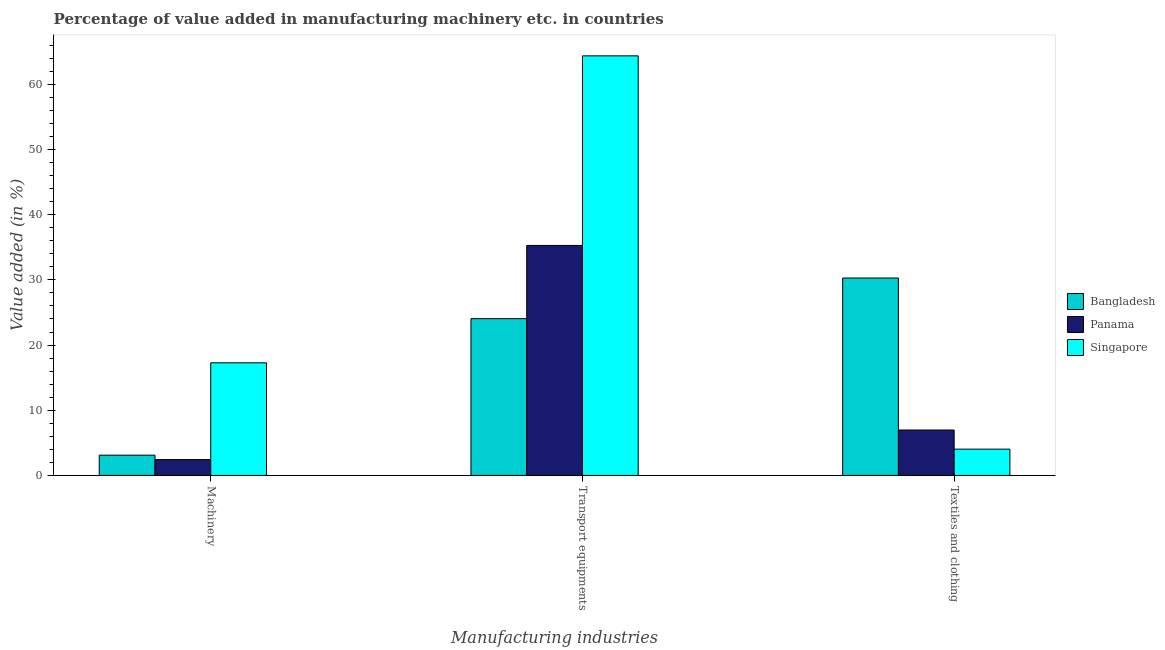How many different coloured bars are there?
Keep it short and to the point. 3. How many groups of bars are there?
Your response must be concise. 3. Are the number of bars per tick equal to the number of legend labels?
Your answer should be compact. Yes. Are the number of bars on each tick of the X-axis equal?
Offer a terse response. Yes. What is the label of the 1st group of bars from the left?
Keep it short and to the point. Machinery. What is the value added in manufacturing machinery in Bangladesh?
Give a very brief answer. 3.11. Across all countries, what is the maximum value added in manufacturing transport equipments?
Offer a terse response. 64.36. Across all countries, what is the minimum value added in manufacturing textile and clothing?
Your answer should be very brief. 4.04. In which country was the value added in manufacturing machinery maximum?
Keep it short and to the point. Singapore. In which country was the value added in manufacturing machinery minimum?
Ensure brevity in your answer.  Panama. What is the total value added in manufacturing machinery in the graph?
Your answer should be very brief. 22.82. What is the difference between the value added in manufacturing machinery in Bangladesh and that in Panama?
Offer a terse response. 0.68. What is the difference between the value added in manufacturing textile and clothing in Bangladesh and the value added in manufacturing transport equipments in Singapore?
Ensure brevity in your answer.  -34.07. What is the average value added in manufacturing transport equipments per country?
Offer a terse response. 41.23. What is the difference between the value added in manufacturing machinery and value added in manufacturing transport equipments in Singapore?
Give a very brief answer. -47.08. What is the ratio of the value added in manufacturing textile and clothing in Panama to that in Bangladesh?
Keep it short and to the point. 0.23. What is the difference between the highest and the second highest value added in manufacturing machinery?
Make the answer very short. 14.16. What is the difference between the highest and the lowest value added in manufacturing machinery?
Your answer should be compact. 14.84. In how many countries, is the value added in manufacturing textile and clothing greater than the average value added in manufacturing textile and clothing taken over all countries?
Provide a short and direct response. 1. Is the sum of the value added in manufacturing machinery in Singapore and Bangladesh greater than the maximum value added in manufacturing transport equipments across all countries?
Ensure brevity in your answer.  No. What does the 2nd bar from the left in Textiles and clothing represents?
Ensure brevity in your answer.  Panama. What does the 2nd bar from the right in Transport equipments represents?
Ensure brevity in your answer.  Panama. Is it the case that in every country, the sum of the value added in manufacturing machinery and value added in manufacturing transport equipments is greater than the value added in manufacturing textile and clothing?
Your response must be concise. No. How many bars are there?
Give a very brief answer. 9. Does the graph contain grids?
Give a very brief answer. No. How many legend labels are there?
Offer a very short reply. 3. What is the title of the graph?
Ensure brevity in your answer.  Percentage of value added in manufacturing machinery etc. in countries. What is the label or title of the X-axis?
Your response must be concise. Manufacturing industries. What is the label or title of the Y-axis?
Your answer should be compact. Value added (in %). What is the Value added (in %) of Bangladesh in Machinery?
Ensure brevity in your answer.  3.11. What is the Value added (in %) of Panama in Machinery?
Keep it short and to the point. 2.43. What is the Value added (in %) of Singapore in Machinery?
Keep it short and to the point. 17.28. What is the Value added (in %) of Bangladesh in Transport equipments?
Ensure brevity in your answer.  24.05. What is the Value added (in %) in Panama in Transport equipments?
Your response must be concise. 35.28. What is the Value added (in %) of Singapore in Transport equipments?
Your answer should be compact. 64.36. What is the Value added (in %) of Bangladesh in Textiles and clothing?
Ensure brevity in your answer.  30.28. What is the Value added (in %) in Panama in Textiles and clothing?
Your answer should be compact. 6.97. What is the Value added (in %) in Singapore in Textiles and clothing?
Your answer should be very brief. 4.04. Across all Manufacturing industries, what is the maximum Value added (in %) of Bangladesh?
Your response must be concise. 30.28. Across all Manufacturing industries, what is the maximum Value added (in %) of Panama?
Offer a very short reply. 35.28. Across all Manufacturing industries, what is the maximum Value added (in %) in Singapore?
Provide a succinct answer. 64.36. Across all Manufacturing industries, what is the minimum Value added (in %) of Bangladesh?
Give a very brief answer. 3.11. Across all Manufacturing industries, what is the minimum Value added (in %) of Panama?
Ensure brevity in your answer.  2.43. Across all Manufacturing industries, what is the minimum Value added (in %) in Singapore?
Offer a terse response. 4.04. What is the total Value added (in %) of Bangladesh in the graph?
Offer a terse response. 57.45. What is the total Value added (in %) of Panama in the graph?
Offer a very short reply. 44.68. What is the total Value added (in %) in Singapore in the graph?
Your response must be concise. 85.67. What is the difference between the Value added (in %) of Bangladesh in Machinery and that in Transport equipments?
Offer a terse response. -20.94. What is the difference between the Value added (in %) in Panama in Machinery and that in Transport equipments?
Keep it short and to the point. -32.84. What is the difference between the Value added (in %) in Singapore in Machinery and that in Transport equipments?
Your answer should be very brief. -47.08. What is the difference between the Value added (in %) of Bangladesh in Machinery and that in Textiles and clothing?
Give a very brief answer. -27.17. What is the difference between the Value added (in %) of Panama in Machinery and that in Textiles and clothing?
Make the answer very short. -4.54. What is the difference between the Value added (in %) of Singapore in Machinery and that in Textiles and clothing?
Offer a terse response. 13.24. What is the difference between the Value added (in %) in Bangladesh in Transport equipments and that in Textiles and clothing?
Offer a terse response. -6.23. What is the difference between the Value added (in %) in Panama in Transport equipments and that in Textiles and clothing?
Your response must be concise. 28.31. What is the difference between the Value added (in %) of Singapore in Transport equipments and that in Textiles and clothing?
Offer a terse response. 60.32. What is the difference between the Value added (in %) in Bangladesh in Machinery and the Value added (in %) in Panama in Transport equipments?
Your answer should be very brief. -32.16. What is the difference between the Value added (in %) in Bangladesh in Machinery and the Value added (in %) in Singapore in Transport equipments?
Provide a short and direct response. -61.24. What is the difference between the Value added (in %) of Panama in Machinery and the Value added (in %) of Singapore in Transport equipments?
Your answer should be compact. -61.92. What is the difference between the Value added (in %) of Bangladesh in Machinery and the Value added (in %) of Panama in Textiles and clothing?
Give a very brief answer. -3.86. What is the difference between the Value added (in %) of Bangladesh in Machinery and the Value added (in %) of Singapore in Textiles and clothing?
Offer a terse response. -0.92. What is the difference between the Value added (in %) in Panama in Machinery and the Value added (in %) in Singapore in Textiles and clothing?
Provide a short and direct response. -1.6. What is the difference between the Value added (in %) in Bangladesh in Transport equipments and the Value added (in %) in Panama in Textiles and clothing?
Keep it short and to the point. 17.08. What is the difference between the Value added (in %) in Bangladesh in Transport equipments and the Value added (in %) in Singapore in Textiles and clothing?
Your answer should be very brief. 20.02. What is the difference between the Value added (in %) in Panama in Transport equipments and the Value added (in %) in Singapore in Textiles and clothing?
Ensure brevity in your answer.  31.24. What is the average Value added (in %) in Bangladesh per Manufacturing industries?
Your response must be concise. 19.15. What is the average Value added (in %) of Panama per Manufacturing industries?
Offer a very short reply. 14.89. What is the average Value added (in %) of Singapore per Manufacturing industries?
Ensure brevity in your answer.  28.56. What is the difference between the Value added (in %) of Bangladesh and Value added (in %) of Panama in Machinery?
Provide a short and direct response. 0.68. What is the difference between the Value added (in %) in Bangladesh and Value added (in %) in Singapore in Machinery?
Give a very brief answer. -14.16. What is the difference between the Value added (in %) in Panama and Value added (in %) in Singapore in Machinery?
Provide a short and direct response. -14.84. What is the difference between the Value added (in %) of Bangladesh and Value added (in %) of Panama in Transport equipments?
Keep it short and to the point. -11.22. What is the difference between the Value added (in %) in Bangladesh and Value added (in %) in Singapore in Transport equipments?
Your answer should be compact. -40.3. What is the difference between the Value added (in %) of Panama and Value added (in %) of Singapore in Transport equipments?
Offer a very short reply. -29.08. What is the difference between the Value added (in %) in Bangladesh and Value added (in %) in Panama in Textiles and clothing?
Give a very brief answer. 23.32. What is the difference between the Value added (in %) in Bangladesh and Value added (in %) in Singapore in Textiles and clothing?
Your answer should be compact. 26.25. What is the difference between the Value added (in %) in Panama and Value added (in %) in Singapore in Textiles and clothing?
Your response must be concise. 2.93. What is the ratio of the Value added (in %) of Bangladesh in Machinery to that in Transport equipments?
Keep it short and to the point. 0.13. What is the ratio of the Value added (in %) of Panama in Machinery to that in Transport equipments?
Your answer should be compact. 0.07. What is the ratio of the Value added (in %) in Singapore in Machinery to that in Transport equipments?
Your response must be concise. 0.27. What is the ratio of the Value added (in %) of Bangladesh in Machinery to that in Textiles and clothing?
Your answer should be compact. 0.1. What is the ratio of the Value added (in %) of Panama in Machinery to that in Textiles and clothing?
Your answer should be very brief. 0.35. What is the ratio of the Value added (in %) in Singapore in Machinery to that in Textiles and clothing?
Your response must be concise. 4.28. What is the ratio of the Value added (in %) in Bangladesh in Transport equipments to that in Textiles and clothing?
Make the answer very short. 0.79. What is the ratio of the Value added (in %) of Panama in Transport equipments to that in Textiles and clothing?
Your answer should be compact. 5.06. What is the ratio of the Value added (in %) in Singapore in Transport equipments to that in Textiles and clothing?
Your response must be concise. 15.95. What is the difference between the highest and the second highest Value added (in %) of Bangladesh?
Your response must be concise. 6.23. What is the difference between the highest and the second highest Value added (in %) of Panama?
Ensure brevity in your answer.  28.31. What is the difference between the highest and the second highest Value added (in %) in Singapore?
Provide a short and direct response. 47.08. What is the difference between the highest and the lowest Value added (in %) of Bangladesh?
Your answer should be compact. 27.17. What is the difference between the highest and the lowest Value added (in %) of Panama?
Ensure brevity in your answer.  32.84. What is the difference between the highest and the lowest Value added (in %) in Singapore?
Offer a very short reply. 60.32. 